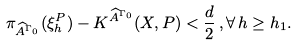Convert formula to latex. <formula><loc_0><loc_0><loc_500><loc_500>\pi _ { \widehat { A } ^ { \Gamma _ { 0 } } } ( \xi _ { h } ^ { P } ) - K ^ { \widehat { A } ^ { \Gamma _ { 0 } } } ( X , P ) < \frac { d } { 2 } \, , \forall \, h \geq h _ { 1 } .</formula> 